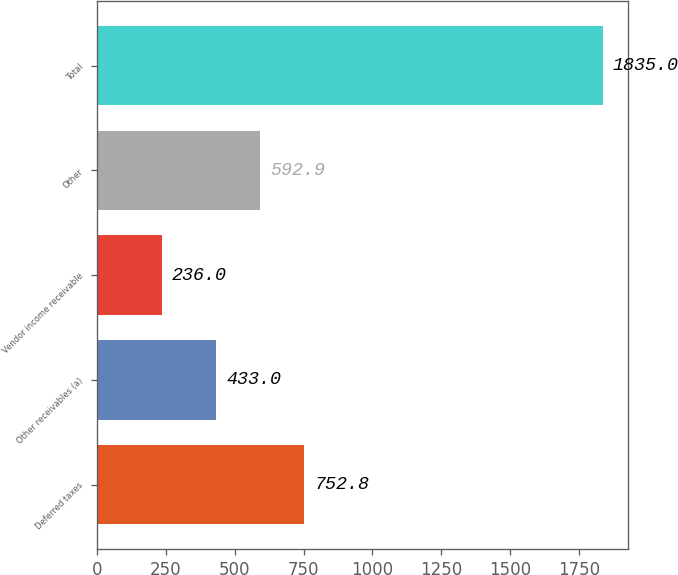Convert chart to OTSL. <chart><loc_0><loc_0><loc_500><loc_500><bar_chart><fcel>Deferred taxes<fcel>Other receivables (a)<fcel>Vendor income receivable<fcel>Other<fcel>Total<nl><fcel>752.8<fcel>433<fcel>236<fcel>592.9<fcel>1835<nl></chart> 